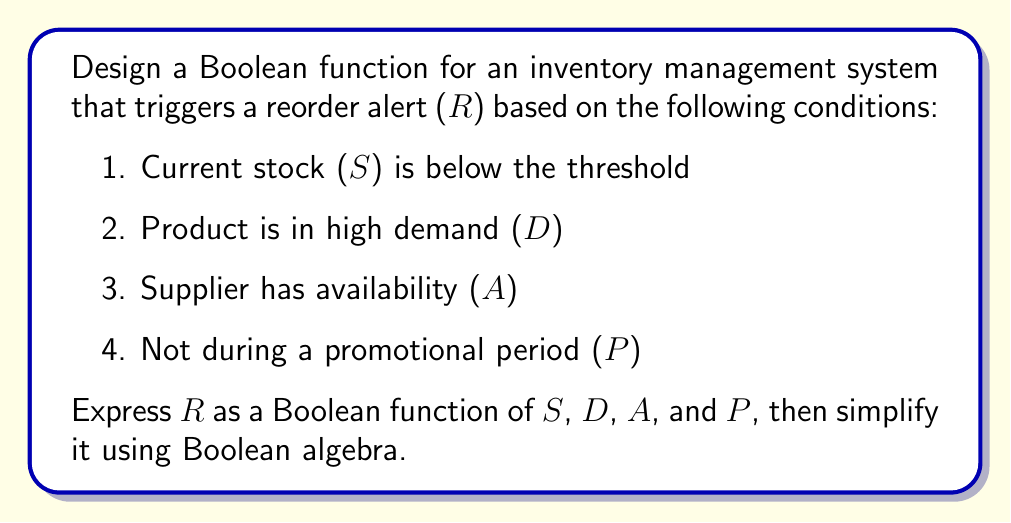Could you help me with this problem? Let's approach this step-by-step:

1) First, we need to express each condition as a Boolean variable:
   S: Current stock is below threshold (1 if true, 0 if false)
   D: Product is in high demand (1 if true, 0 if false)
   A: Supplier has availability (1 if true, 0 if false)
   P: During promotional period (1 if true, 0 if false)

2) The reorder alert (R) should trigger when all conditions are met:
   R = S AND D AND A AND (NOT P)

3) In Boolean algebra, this can be written as:
   $$R = S \cdot D \cdot A \cdot \overline{P}$$

4) This expression is already in its simplest form as it uses only AND operations and one NOT operation. However, we can verify this using Boolean algebra laws:

   a) Commutative law: The order of variables doesn't matter in AND operations.
   b) Associative law: We can group the variables in any way without changing the result.
   c) Distributive law: Doesn't apply here as we don't have any OR operations.
   d) De Morgan's laws: Don't apply as we don't have nested NOT operations.

5) Therefore, the final simplified Boolean function is:
   $$R = S \cdot D \cdot A \cdot \overline{P}$$

This function will output 1 (triggering a reorder alert) only when all conditions are met: stock is low, demand is high, supplier has availability, and it's not during a promotional period.
Answer: $$R = S \cdot D \cdot A \cdot \overline{P}$$ 